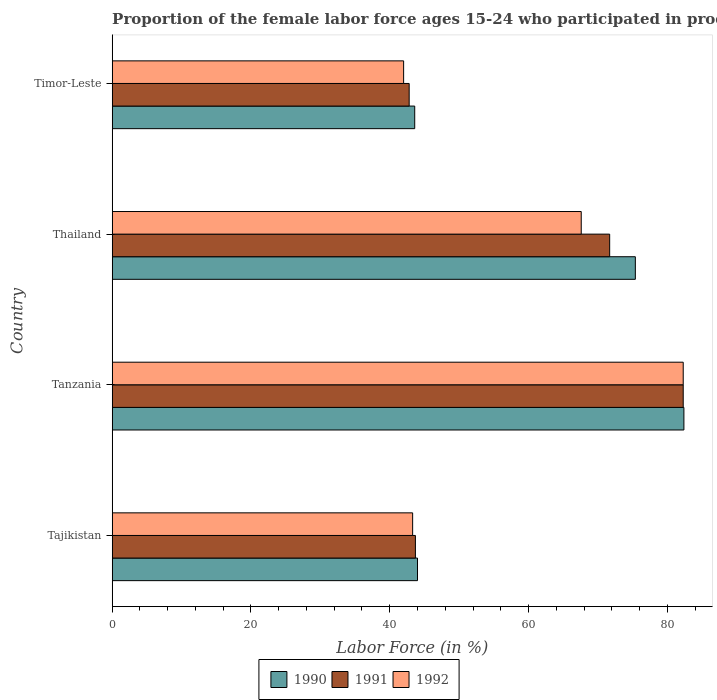How many different coloured bars are there?
Your answer should be compact. 3. Are the number of bars on each tick of the Y-axis equal?
Offer a very short reply. Yes. What is the label of the 4th group of bars from the top?
Offer a very short reply. Tajikistan. What is the proportion of the female labor force who participated in production in 1990 in Thailand?
Offer a very short reply. 75.4. Across all countries, what is the maximum proportion of the female labor force who participated in production in 1990?
Offer a very short reply. 82.4. Across all countries, what is the minimum proportion of the female labor force who participated in production in 1992?
Make the answer very short. 42. In which country was the proportion of the female labor force who participated in production in 1991 maximum?
Make the answer very short. Tanzania. In which country was the proportion of the female labor force who participated in production in 1991 minimum?
Your answer should be compact. Timor-Leste. What is the total proportion of the female labor force who participated in production in 1991 in the graph?
Provide a succinct answer. 240.5. What is the difference between the proportion of the female labor force who participated in production in 1992 in Tanzania and that in Thailand?
Offer a very short reply. 14.7. What is the difference between the proportion of the female labor force who participated in production in 1991 in Thailand and the proportion of the female labor force who participated in production in 1990 in Tanzania?
Make the answer very short. -10.7. What is the average proportion of the female labor force who participated in production in 1991 per country?
Make the answer very short. 60.12. What is the difference between the proportion of the female labor force who participated in production in 1991 and proportion of the female labor force who participated in production in 1990 in Tanzania?
Offer a very short reply. -0.1. What is the ratio of the proportion of the female labor force who participated in production in 1991 in Tanzania to that in Thailand?
Your answer should be compact. 1.15. Is the proportion of the female labor force who participated in production in 1992 in Tanzania less than that in Timor-Leste?
Your answer should be very brief. No. Is the difference between the proportion of the female labor force who participated in production in 1991 in Tajikistan and Timor-Leste greater than the difference between the proportion of the female labor force who participated in production in 1990 in Tajikistan and Timor-Leste?
Your response must be concise. Yes. What is the difference between the highest and the second highest proportion of the female labor force who participated in production in 1990?
Give a very brief answer. 7. What is the difference between the highest and the lowest proportion of the female labor force who participated in production in 1991?
Provide a short and direct response. 39.5. Is the sum of the proportion of the female labor force who participated in production in 1992 in Tajikistan and Thailand greater than the maximum proportion of the female labor force who participated in production in 1990 across all countries?
Your answer should be very brief. Yes. Is it the case that in every country, the sum of the proportion of the female labor force who participated in production in 1991 and proportion of the female labor force who participated in production in 1992 is greater than the proportion of the female labor force who participated in production in 1990?
Make the answer very short. Yes. How many bars are there?
Your response must be concise. 12. What is the difference between two consecutive major ticks on the X-axis?
Your answer should be compact. 20. What is the title of the graph?
Ensure brevity in your answer.  Proportion of the female labor force ages 15-24 who participated in production. What is the label or title of the X-axis?
Keep it short and to the point. Labor Force (in %). What is the Labor Force (in %) in 1991 in Tajikistan?
Give a very brief answer. 43.7. What is the Labor Force (in %) in 1992 in Tajikistan?
Your response must be concise. 43.3. What is the Labor Force (in %) of 1990 in Tanzania?
Keep it short and to the point. 82.4. What is the Labor Force (in %) in 1991 in Tanzania?
Your answer should be compact. 82.3. What is the Labor Force (in %) in 1992 in Tanzania?
Offer a terse response. 82.3. What is the Labor Force (in %) in 1990 in Thailand?
Ensure brevity in your answer.  75.4. What is the Labor Force (in %) in 1991 in Thailand?
Ensure brevity in your answer.  71.7. What is the Labor Force (in %) in 1992 in Thailand?
Provide a short and direct response. 67.6. What is the Labor Force (in %) of 1990 in Timor-Leste?
Give a very brief answer. 43.6. What is the Labor Force (in %) in 1991 in Timor-Leste?
Ensure brevity in your answer.  42.8. What is the Labor Force (in %) in 1992 in Timor-Leste?
Your answer should be very brief. 42. Across all countries, what is the maximum Labor Force (in %) in 1990?
Offer a terse response. 82.4. Across all countries, what is the maximum Labor Force (in %) of 1991?
Offer a terse response. 82.3. Across all countries, what is the maximum Labor Force (in %) in 1992?
Keep it short and to the point. 82.3. Across all countries, what is the minimum Labor Force (in %) in 1990?
Your answer should be compact. 43.6. Across all countries, what is the minimum Labor Force (in %) of 1991?
Offer a very short reply. 42.8. Across all countries, what is the minimum Labor Force (in %) of 1992?
Make the answer very short. 42. What is the total Labor Force (in %) of 1990 in the graph?
Keep it short and to the point. 245.4. What is the total Labor Force (in %) in 1991 in the graph?
Provide a short and direct response. 240.5. What is the total Labor Force (in %) in 1992 in the graph?
Make the answer very short. 235.2. What is the difference between the Labor Force (in %) of 1990 in Tajikistan and that in Tanzania?
Offer a terse response. -38.4. What is the difference between the Labor Force (in %) in 1991 in Tajikistan and that in Tanzania?
Ensure brevity in your answer.  -38.6. What is the difference between the Labor Force (in %) in 1992 in Tajikistan and that in Tanzania?
Your response must be concise. -39. What is the difference between the Labor Force (in %) of 1990 in Tajikistan and that in Thailand?
Your answer should be very brief. -31.4. What is the difference between the Labor Force (in %) of 1992 in Tajikistan and that in Thailand?
Your response must be concise. -24.3. What is the difference between the Labor Force (in %) of 1990 in Tajikistan and that in Timor-Leste?
Provide a short and direct response. 0.4. What is the difference between the Labor Force (in %) of 1991 in Tajikistan and that in Timor-Leste?
Provide a short and direct response. 0.9. What is the difference between the Labor Force (in %) in 1992 in Tajikistan and that in Timor-Leste?
Provide a succinct answer. 1.3. What is the difference between the Labor Force (in %) of 1991 in Tanzania and that in Thailand?
Give a very brief answer. 10.6. What is the difference between the Labor Force (in %) of 1992 in Tanzania and that in Thailand?
Your answer should be very brief. 14.7. What is the difference between the Labor Force (in %) of 1990 in Tanzania and that in Timor-Leste?
Keep it short and to the point. 38.8. What is the difference between the Labor Force (in %) of 1991 in Tanzania and that in Timor-Leste?
Keep it short and to the point. 39.5. What is the difference between the Labor Force (in %) of 1992 in Tanzania and that in Timor-Leste?
Offer a terse response. 40.3. What is the difference between the Labor Force (in %) in 1990 in Thailand and that in Timor-Leste?
Offer a very short reply. 31.8. What is the difference between the Labor Force (in %) in 1991 in Thailand and that in Timor-Leste?
Ensure brevity in your answer.  28.9. What is the difference between the Labor Force (in %) of 1992 in Thailand and that in Timor-Leste?
Provide a short and direct response. 25.6. What is the difference between the Labor Force (in %) in 1990 in Tajikistan and the Labor Force (in %) in 1991 in Tanzania?
Provide a short and direct response. -38.3. What is the difference between the Labor Force (in %) of 1990 in Tajikistan and the Labor Force (in %) of 1992 in Tanzania?
Offer a terse response. -38.3. What is the difference between the Labor Force (in %) of 1991 in Tajikistan and the Labor Force (in %) of 1992 in Tanzania?
Provide a short and direct response. -38.6. What is the difference between the Labor Force (in %) in 1990 in Tajikistan and the Labor Force (in %) in 1991 in Thailand?
Offer a terse response. -27.7. What is the difference between the Labor Force (in %) of 1990 in Tajikistan and the Labor Force (in %) of 1992 in Thailand?
Offer a terse response. -23.6. What is the difference between the Labor Force (in %) in 1991 in Tajikistan and the Labor Force (in %) in 1992 in Thailand?
Give a very brief answer. -23.9. What is the difference between the Labor Force (in %) of 1990 in Tajikistan and the Labor Force (in %) of 1992 in Timor-Leste?
Offer a terse response. 2. What is the difference between the Labor Force (in %) of 1990 in Tanzania and the Labor Force (in %) of 1991 in Thailand?
Keep it short and to the point. 10.7. What is the difference between the Labor Force (in %) in 1990 in Tanzania and the Labor Force (in %) in 1991 in Timor-Leste?
Give a very brief answer. 39.6. What is the difference between the Labor Force (in %) in 1990 in Tanzania and the Labor Force (in %) in 1992 in Timor-Leste?
Give a very brief answer. 40.4. What is the difference between the Labor Force (in %) in 1991 in Tanzania and the Labor Force (in %) in 1992 in Timor-Leste?
Keep it short and to the point. 40.3. What is the difference between the Labor Force (in %) of 1990 in Thailand and the Labor Force (in %) of 1991 in Timor-Leste?
Provide a succinct answer. 32.6. What is the difference between the Labor Force (in %) in 1990 in Thailand and the Labor Force (in %) in 1992 in Timor-Leste?
Ensure brevity in your answer.  33.4. What is the difference between the Labor Force (in %) in 1991 in Thailand and the Labor Force (in %) in 1992 in Timor-Leste?
Provide a short and direct response. 29.7. What is the average Labor Force (in %) of 1990 per country?
Your answer should be very brief. 61.35. What is the average Labor Force (in %) in 1991 per country?
Your answer should be compact. 60.12. What is the average Labor Force (in %) in 1992 per country?
Offer a terse response. 58.8. What is the difference between the Labor Force (in %) of 1990 and Labor Force (in %) of 1991 in Thailand?
Give a very brief answer. 3.7. What is the difference between the Labor Force (in %) of 1990 and Labor Force (in %) of 1992 in Thailand?
Your response must be concise. 7.8. What is the difference between the Labor Force (in %) in 1990 and Labor Force (in %) in 1992 in Timor-Leste?
Your answer should be compact. 1.6. What is the difference between the Labor Force (in %) of 1991 and Labor Force (in %) of 1992 in Timor-Leste?
Offer a terse response. 0.8. What is the ratio of the Labor Force (in %) of 1990 in Tajikistan to that in Tanzania?
Your response must be concise. 0.53. What is the ratio of the Labor Force (in %) of 1991 in Tajikistan to that in Tanzania?
Provide a short and direct response. 0.53. What is the ratio of the Labor Force (in %) in 1992 in Tajikistan to that in Tanzania?
Your answer should be very brief. 0.53. What is the ratio of the Labor Force (in %) of 1990 in Tajikistan to that in Thailand?
Keep it short and to the point. 0.58. What is the ratio of the Labor Force (in %) in 1991 in Tajikistan to that in Thailand?
Offer a terse response. 0.61. What is the ratio of the Labor Force (in %) in 1992 in Tajikistan to that in Thailand?
Provide a succinct answer. 0.64. What is the ratio of the Labor Force (in %) in 1990 in Tajikistan to that in Timor-Leste?
Your response must be concise. 1.01. What is the ratio of the Labor Force (in %) of 1992 in Tajikistan to that in Timor-Leste?
Your answer should be compact. 1.03. What is the ratio of the Labor Force (in %) in 1990 in Tanzania to that in Thailand?
Offer a terse response. 1.09. What is the ratio of the Labor Force (in %) in 1991 in Tanzania to that in Thailand?
Make the answer very short. 1.15. What is the ratio of the Labor Force (in %) of 1992 in Tanzania to that in Thailand?
Your answer should be very brief. 1.22. What is the ratio of the Labor Force (in %) in 1990 in Tanzania to that in Timor-Leste?
Offer a terse response. 1.89. What is the ratio of the Labor Force (in %) in 1991 in Tanzania to that in Timor-Leste?
Offer a terse response. 1.92. What is the ratio of the Labor Force (in %) in 1992 in Tanzania to that in Timor-Leste?
Give a very brief answer. 1.96. What is the ratio of the Labor Force (in %) of 1990 in Thailand to that in Timor-Leste?
Offer a very short reply. 1.73. What is the ratio of the Labor Force (in %) of 1991 in Thailand to that in Timor-Leste?
Ensure brevity in your answer.  1.68. What is the ratio of the Labor Force (in %) in 1992 in Thailand to that in Timor-Leste?
Your response must be concise. 1.61. What is the difference between the highest and the second highest Labor Force (in %) in 1990?
Make the answer very short. 7. What is the difference between the highest and the second highest Labor Force (in %) in 1991?
Keep it short and to the point. 10.6. What is the difference between the highest and the second highest Labor Force (in %) of 1992?
Keep it short and to the point. 14.7. What is the difference between the highest and the lowest Labor Force (in %) in 1990?
Provide a succinct answer. 38.8. What is the difference between the highest and the lowest Labor Force (in %) of 1991?
Provide a short and direct response. 39.5. What is the difference between the highest and the lowest Labor Force (in %) in 1992?
Your answer should be very brief. 40.3. 